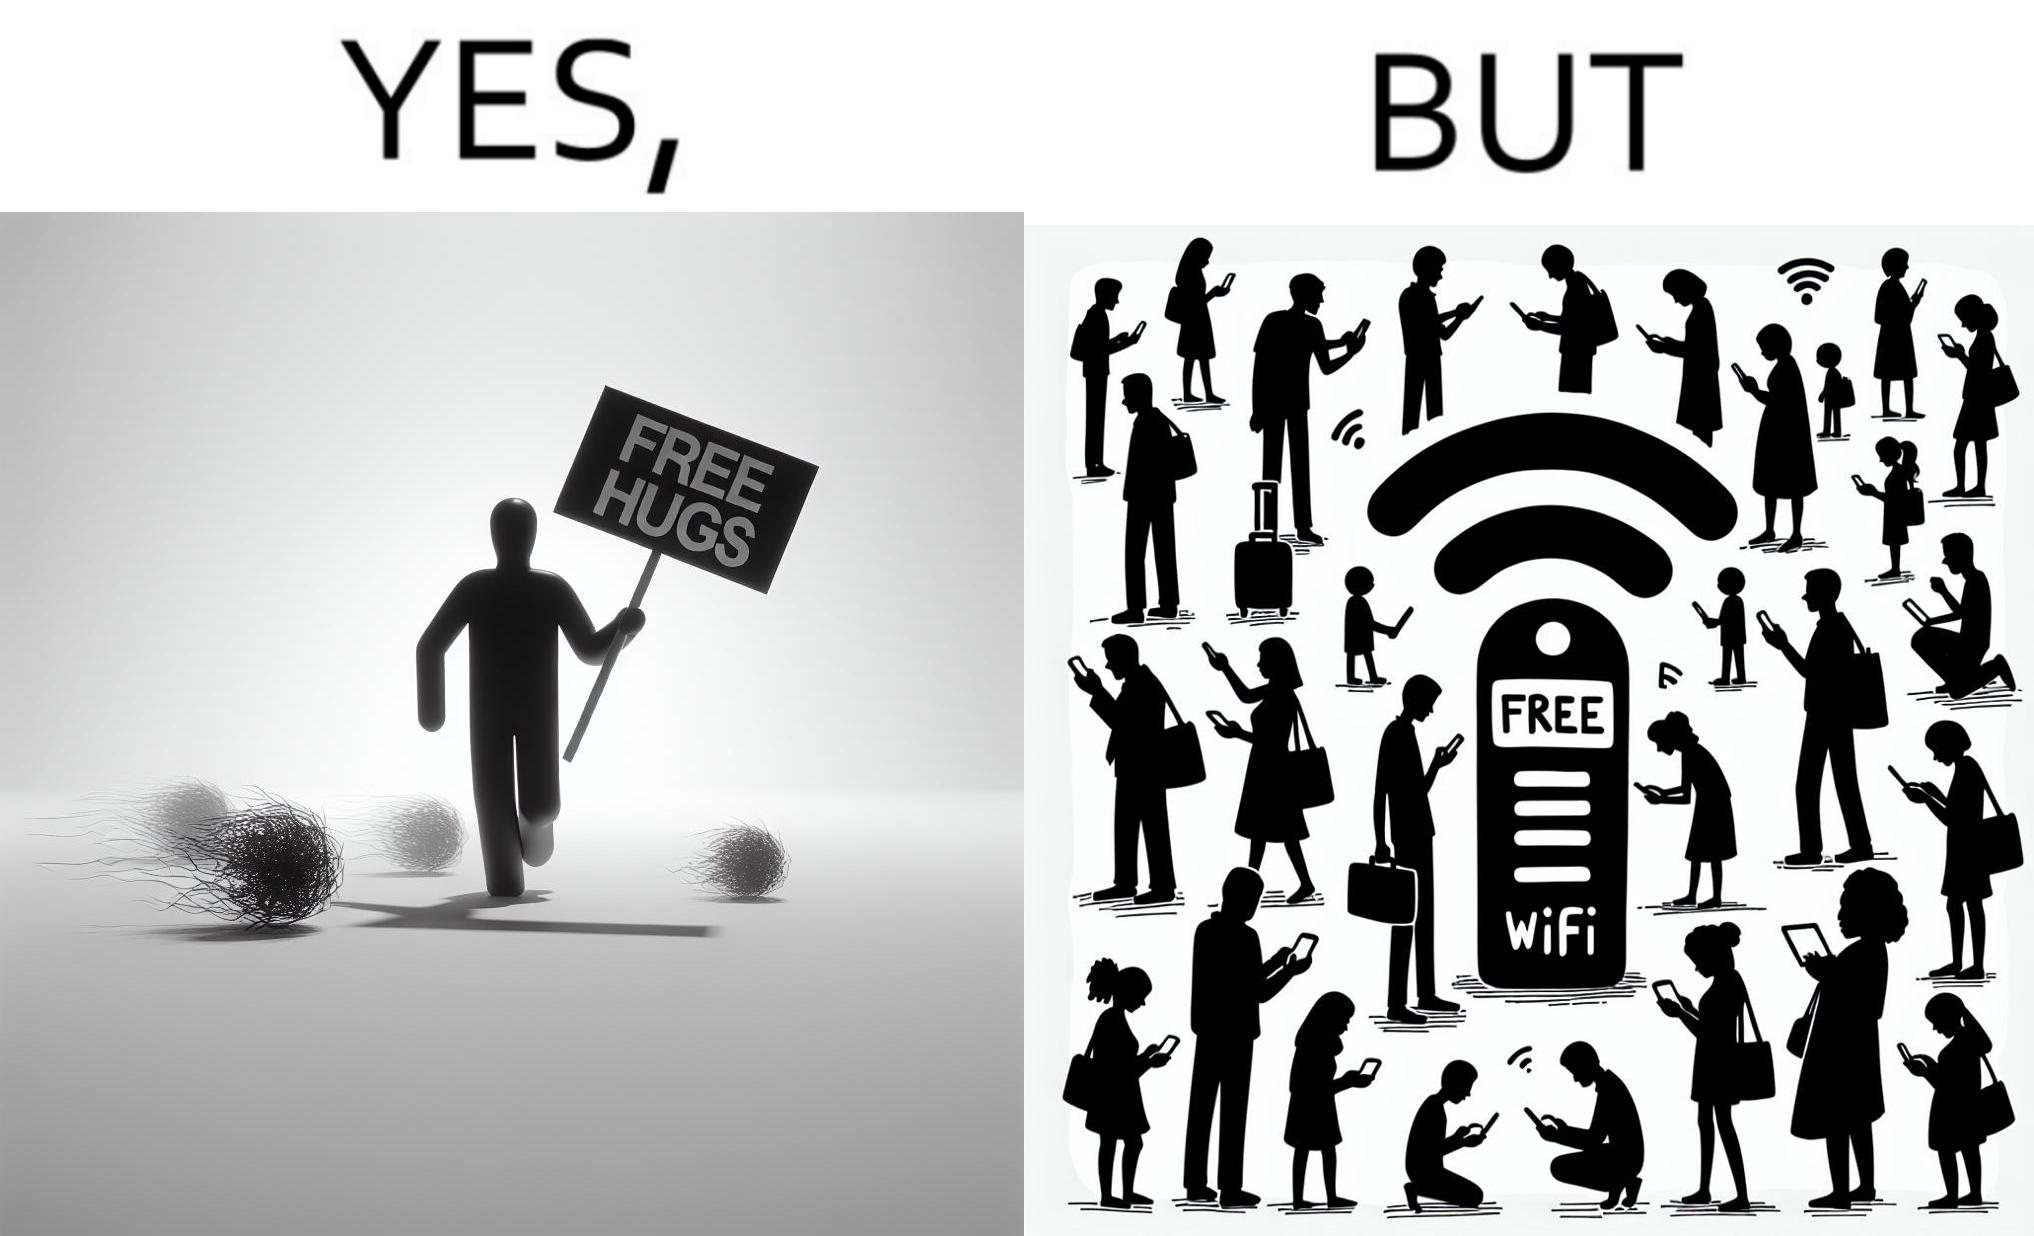What makes this image funny or satirical? This image is ironical, as a person holding up a "Free Hugs" sign is standing alone, while an inanimate Wi-fi Router giving "Free Wifi" is surrounded people trying to connect to it. This shows a growing lack of empathy in our society, while showing our increasing dependence on the digital devices in a virtual world. 